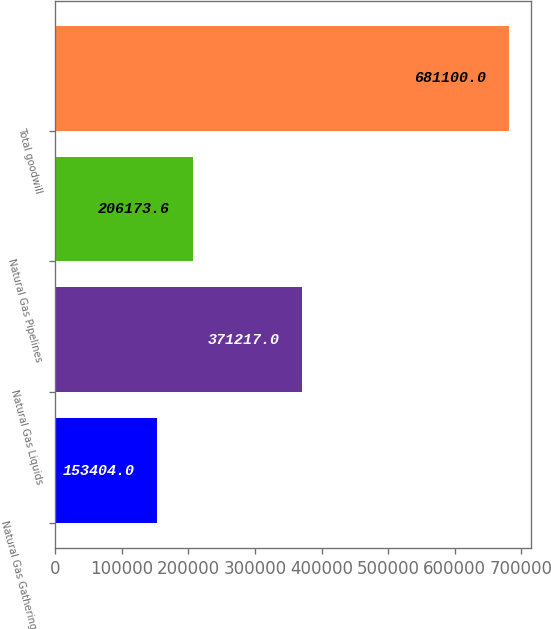<chart> <loc_0><loc_0><loc_500><loc_500><bar_chart><fcel>Natural Gas Gathering and<fcel>Natural Gas Liquids<fcel>Natural Gas Pipelines<fcel>Total goodwill<nl><fcel>153404<fcel>371217<fcel>206174<fcel>681100<nl></chart> 